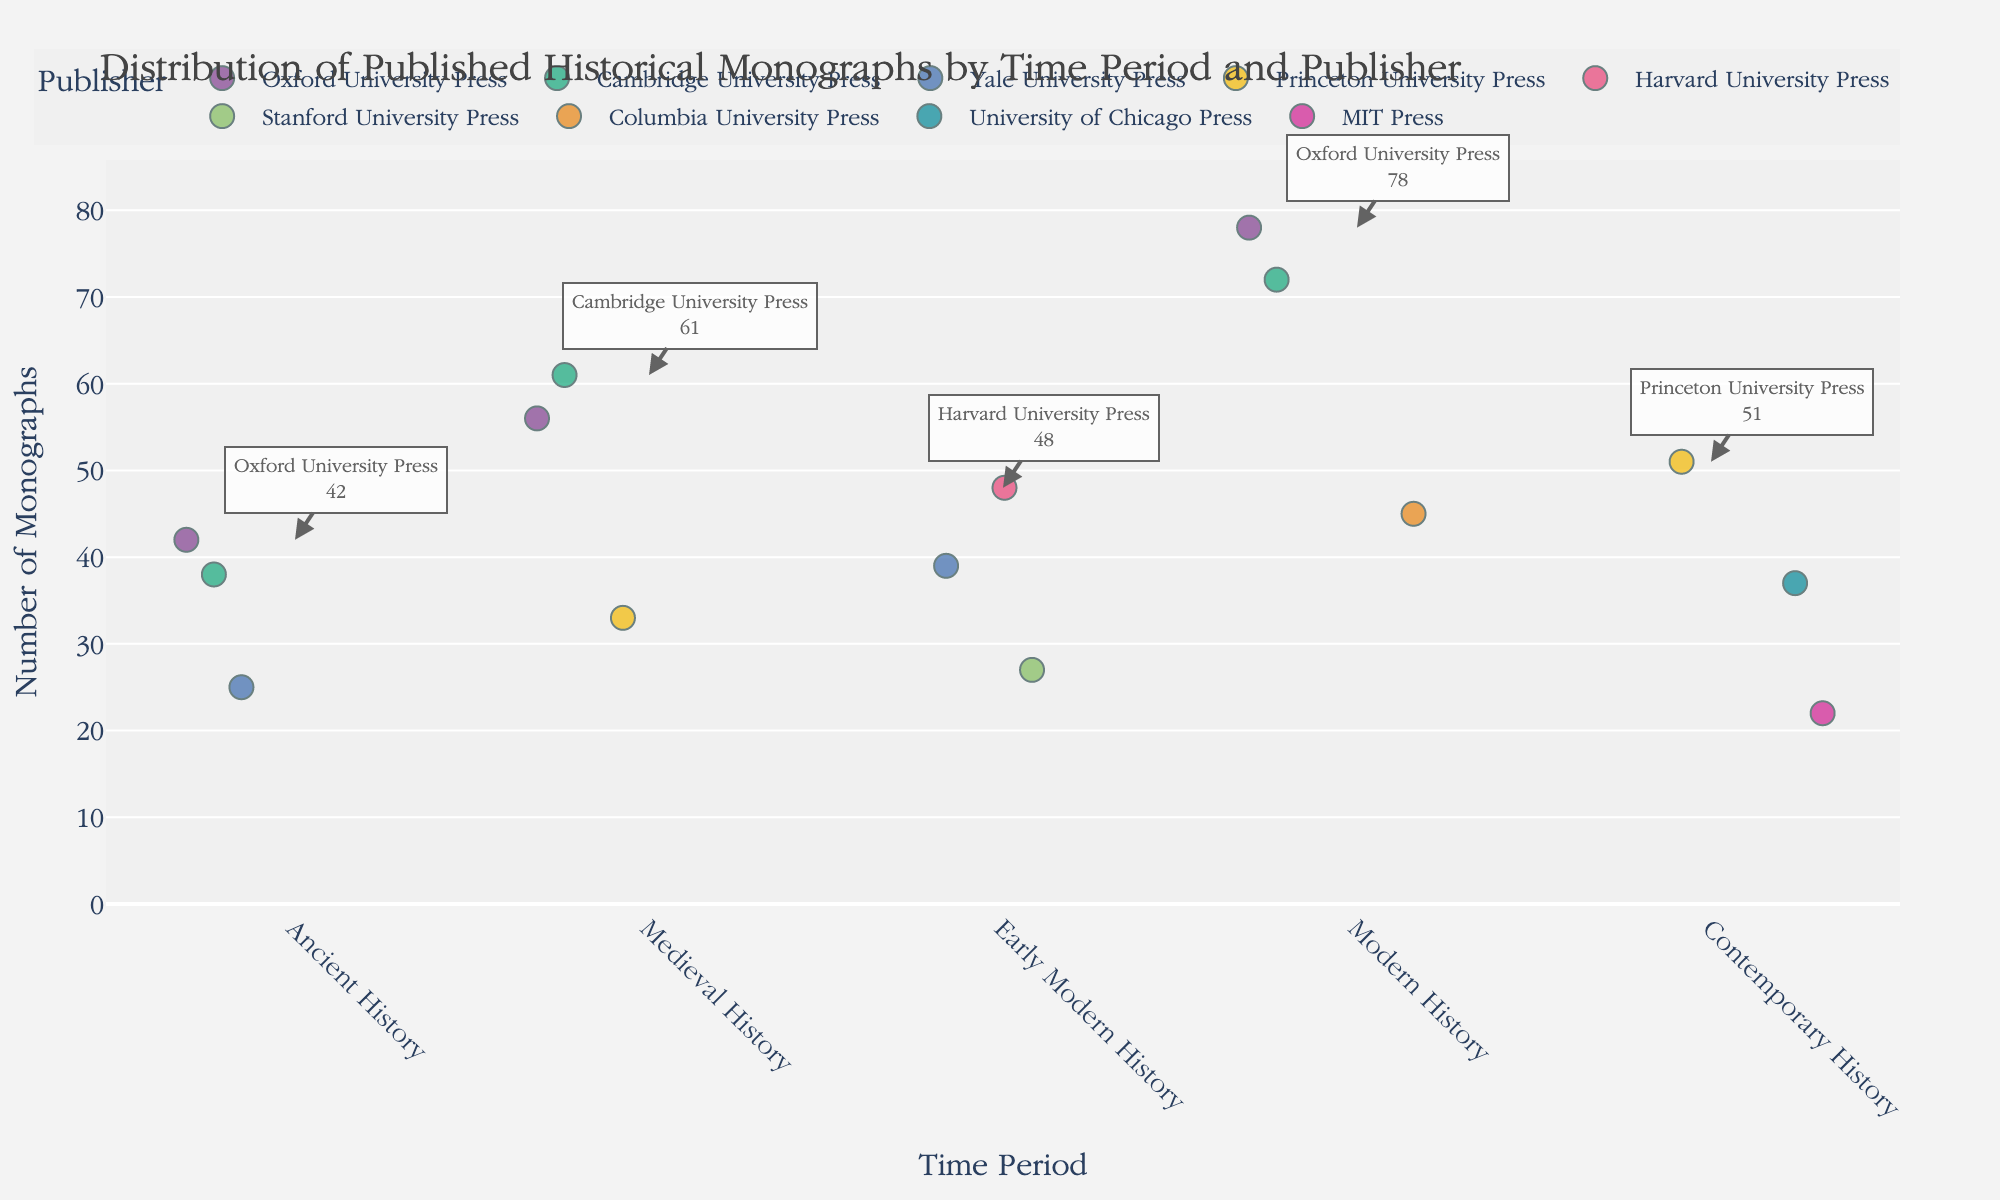How many monographs were published by Oxford University Press across all periods? Sum the number of monographs published by Oxford University Press in each time period: Ancient History (42), Medieval History (56), Modern History (78). So, 42 + 56 + 78 = 176.
Answer: 176 Which publisher has the highest number of monographs in Modern History? Look at the points in the Modern History category and identify the publisher with the highest y-value. The publishers and their respective monographs are Oxford University Press (78), Cambridge University Press (72), and Columbia University Press (45). Oxford University Press has the highest number.
Answer: Oxford University Press Between Ancient and Contemporary History, which period has fewer total monographs published? Calculate the total monographs in Ancient History (42 + 38 + 25 = 105) and in Contemporary History (51 + 37 + 22 = 110). Compare the two totals.
Answer: Ancient History What is the average number of monographs published in Early Modern History? Add the number of monographs in Early Modern History (48 + 39 + 27), then divide by the number of publishers (3). (48 + 39 + 27) / 3 = 38.
Answer: 38 Which time period shows the most diverse range of monographs published across different publishers? Observe the range of monographs (difference between highest and lowest values) for each time period. Calculate as follows:
- Ancient History: 42 - 25 = 17
- Medieval History: 61 - 33 = 28
- Early Modern History: 48 - 27 = 21
- Modern History: 78 - 45 = 33
- Contemporary History: 51 - 22 = 29
Modern History has the widest range (33).
Answer: Modern History How many publishers are represented in the Contemporary History period? Count the number of distinct publishers in the Contemporary History category: Princeton University Press, University of Chicago Press, and MIT Press.
Answer: 3 What is the difference in the number of monographs published by Cambridge University Press between Medieval History and Modern History? Find the number of monographs for Cambridge University Press in each period: Medieval History (61) and Modern History (72). Calculate the difference: 72 - 61 = 11.
Answer: 11 Which publisher has the lowest number of monographs in any period, and what is that number? Identify the point with the lowest y-value across all time periods. MIT Press in Contemporary History with 22 monographs.
Answer: MIT Press, 22 